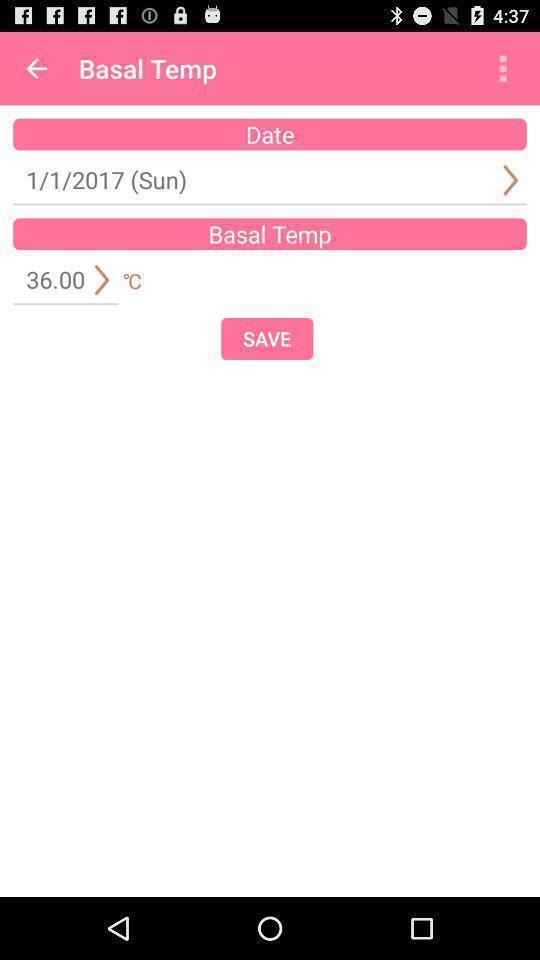Explain the elements present in this screenshot. Scheduled activity in the application to save. 